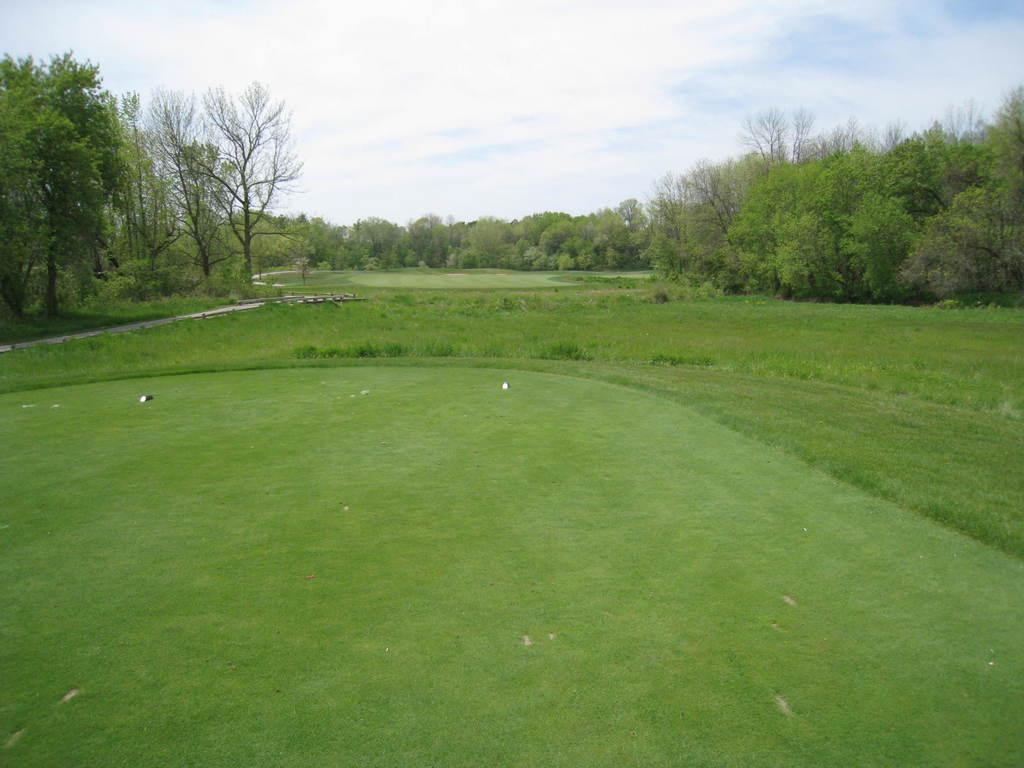What type of vegetation is present in the image? There are trees and grass in the image. What can be seen in the background of the image? The sky is visible in the background of the image. How many spiders are crawling on the trees in the image? There are no spiders visible in the image; it only features trees and grass. What is the father doing in the image? There is no reference to a father or any person in the image, so it is not possible to answer that question. 